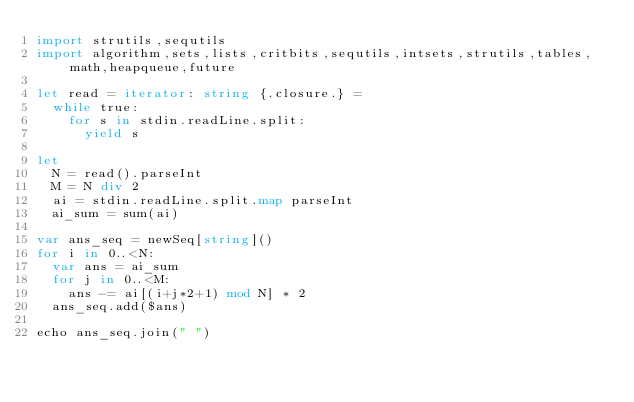Convert code to text. <code><loc_0><loc_0><loc_500><loc_500><_Nim_>import strutils,sequtils
import algorithm,sets,lists,critbits,sequtils,intsets,strutils,tables,math,heapqueue,future

let read = iterator: string {.closure.} =
  while true:
    for s in stdin.readLine.split:
      yield s

let
  N = read().parseInt
  M = N div 2
  ai = stdin.readLine.split.map parseInt
  ai_sum = sum(ai)

var ans_seq = newSeq[string]()
for i in 0..<N:
  var ans = ai_sum
  for j in 0..<M:
    ans -= ai[(i+j*2+1) mod N] * 2
  ans_seq.add($ans)

echo ans_seq.join(" ")
</code> 